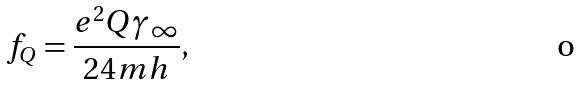Convert formula to latex. <formula><loc_0><loc_0><loc_500><loc_500>f _ { Q } = \frac { e ^ { 2 } Q \gamma _ { \infty } } { 2 4 m h } ,</formula> 